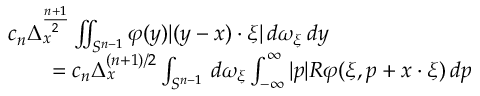<formula> <loc_0><loc_0><loc_500><loc_500>{ \begin{array} { r l } & { c _ { n } \Delta _ { x } ^ { \frac { n + 1 } { 2 } } \iint _ { S ^ { n - 1 } } \varphi ( y ) | ( y - x ) \cdot \xi | \, d \omega _ { \xi } \, d y } \\ & { \quad = c _ { n } \Delta _ { x } ^ { ( n + 1 ) / 2 } \int _ { S ^ { n - 1 } } \, d \omega _ { \xi } \int _ { - \infty } ^ { \infty } | p | R \varphi ( \xi , p + x \cdot \xi ) \, d p } \end{array} }</formula> 